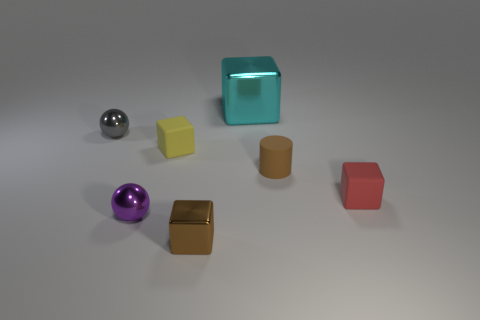Is there any other thing that has the same shape as the tiny brown rubber thing?
Offer a very short reply. No. Are there any other things that are the same size as the cyan metallic thing?
Your answer should be compact. No. What color is the cylinder that is made of the same material as the red thing?
Provide a short and direct response. Brown. Are the red cube and the sphere behind the yellow cube made of the same material?
Give a very brief answer. No. What is the color of the tiny block that is both behind the purple object and left of the small red thing?
Keep it short and to the point. Yellow. How many cubes are large cyan objects or small red rubber things?
Offer a terse response. 2. Does the yellow matte thing have the same shape as the tiny brown object that is behind the small brown shiny object?
Your answer should be very brief. No. How big is the block that is both in front of the brown rubber thing and left of the small brown rubber cylinder?
Give a very brief answer. Small. What is the shape of the brown metallic object?
Your response must be concise. Cube. Is there a cyan object on the left side of the rubber cube that is to the left of the large cyan metal object?
Your answer should be compact. No. 